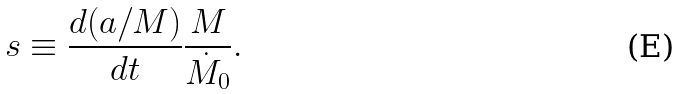Convert formula to latex. <formula><loc_0><loc_0><loc_500><loc_500>s \equiv \frac { d ( a / M ) } { d t } \frac { M } { \dot { M } _ { 0 } } .</formula> 